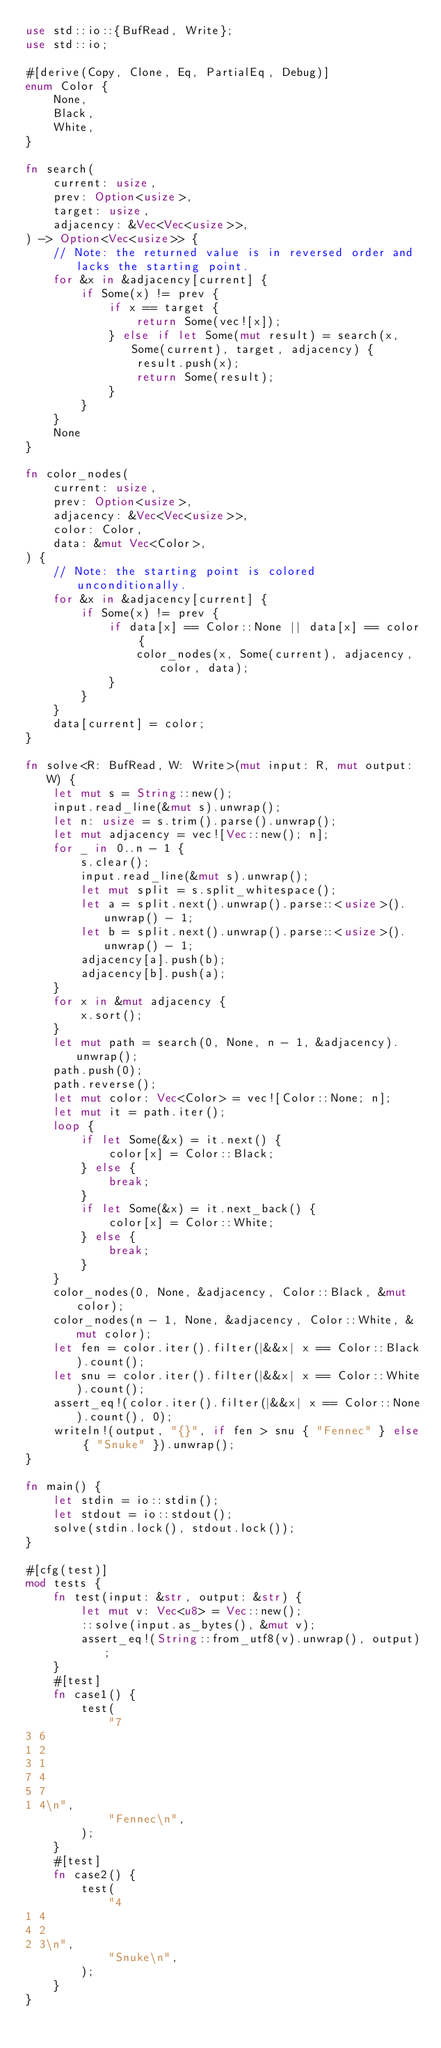<code> <loc_0><loc_0><loc_500><loc_500><_Rust_>use std::io::{BufRead, Write};
use std::io;

#[derive(Copy, Clone, Eq, PartialEq, Debug)]
enum Color {
    None,
    Black,
    White,
}

fn search(
    current: usize,
    prev: Option<usize>,
    target: usize,
    adjacency: &Vec<Vec<usize>>,
) -> Option<Vec<usize>> {
    // Note: the returned value is in reversed order and lacks the starting point.
    for &x in &adjacency[current] {
        if Some(x) != prev {
            if x == target {
                return Some(vec![x]);
            } else if let Some(mut result) = search(x, Some(current), target, adjacency) {
                result.push(x);
                return Some(result);
            }
        }
    }
    None
}

fn color_nodes(
    current: usize,
    prev: Option<usize>,
    adjacency: &Vec<Vec<usize>>,
    color: Color,
    data: &mut Vec<Color>,
) {
    // Note: the starting point is colored unconditionally.
    for &x in &adjacency[current] {
        if Some(x) != prev {
            if data[x] == Color::None || data[x] == color {
                color_nodes(x, Some(current), adjacency, color, data);
            }
        }
    }
    data[current] = color;
}

fn solve<R: BufRead, W: Write>(mut input: R, mut output: W) {
    let mut s = String::new();
    input.read_line(&mut s).unwrap();
    let n: usize = s.trim().parse().unwrap();
    let mut adjacency = vec![Vec::new(); n];
    for _ in 0..n - 1 {
        s.clear();
        input.read_line(&mut s).unwrap();
        let mut split = s.split_whitespace();
        let a = split.next().unwrap().parse::<usize>().unwrap() - 1;
        let b = split.next().unwrap().parse::<usize>().unwrap() - 1;
        adjacency[a].push(b);
        adjacency[b].push(a);
    }
    for x in &mut adjacency {
        x.sort();
    }
    let mut path = search(0, None, n - 1, &adjacency).unwrap();
    path.push(0);
    path.reverse();
    let mut color: Vec<Color> = vec![Color::None; n];
    let mut it = path.iter();
    loop {
        if let Some(&x) = it.next() {
            color[x] = Color::Black;
        } else {
            break;
        }
        if let Some(&x) = it.next_back() {
            color[x] = Color::White;
        } else {
            break;
        }
    }
    color_nodes(0, None, &adjacency, Color::Black, &mut color);
    color_nodes(n - 1, None, &adjacency, Color::White, &mut color);
    let fen = color.iter().filter(|&&x| x == Color::Black).count();
    let snu = color.iter().filter(|&&x| x == Color::White).count();
    assert_eq!(color.iter().filter(|&&x| x == Color::None).count(), 0);
    writeln!(output, "{}", if fen > snu { "Fennec" } else { "Snuke" }).unwrap();
}

fn main() {
    let stdin = io::stdin();
    let stdout = io::stdout();
    solve(stdin.lock(), stdout.lock());
}

#[cfg(test)]
mod tests {
    fn test(input: &str, output: &str) {
        let mut v: Vec<u8> = Vec::new();
        ::solve(input.as_bytes(), &mut v);
        assert_eq!(String::from_utf8(v).unwrap(), output);
    }
    #[test]
    fn case1() {
        test(
            "7
3 6
1 2
3 1
7 4
5 7
1 4\n",
            "Fennec\n",
        );
    }
    #[test]
    fn case2() {
        test(
            "4
1 4
4 2
2 3\n",
            "Snuke\n",
        );
    }
}
</code> 